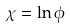<formula> <loc_0><loc_0><loc_500><loc_500>\chi = \ln \phi</formula> 